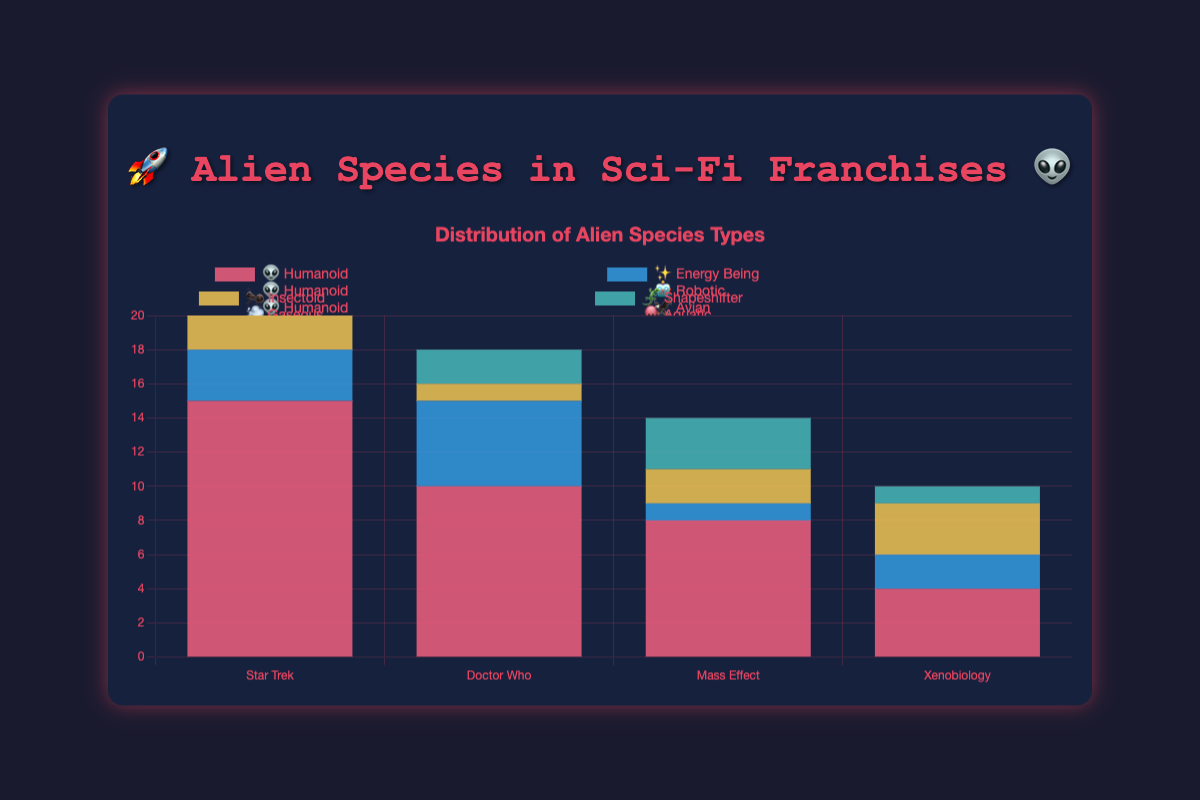What is the title of the chart? The title is displayed above the chart and should briefly describe the content. In this case, it is clearly stated at the top.
Answer: 🚀 Alien Species in Sci-Fi Franchises 👽 Which alien type has the highest count in the "Star Trek" franchise? By observing the bars corresponding to the "Star Trek" franchise, the tallest bar indicates the alien type with the highest count. The "Humanoid" type (👽) has the highest count.
Answer: Humanoid 👽 How many "Energy Being" (✨) aliens are there in "Star Trek"? Look at the specific bar for "Energy Being" (✨) in the "Star Trek" section of the chart. It shows a count of 3.
Answer: 3 Which franchise has the most "Robotic" (🤖) aliens? Compare the "Robotic" (🤖) bars across all franchises. "Doctor Who" has the highest bar for "Robotic" type with a count of 5.
Answer: Doctor Who What is the total number of "Humanoid" (👽) aliens across all franchises? Sum the counts of "Humanoid" aliens for each franchise: 15 (Star Trek) + 10 (Doctor Who) + 8 (Mass Effect) = 33.
Answer: 33 Are there any franchises with "Aquatic" (🐙) aliens? If so, which ones? Inspect the chart for any bars labeled "Aquatic" (🐙). The "Doctor Who" franchise has a bar for "Aquatic" aliens.
Answer: Doctor Who Which franchise has the least variety of alien types? Look at the number of different alien type bars for each franchise. "Mass Effect" has 4 types, while "Xenobiology" has more varied types but groups similar ones together.
Answer: Star Trek How does the count of "Synthetic" (🤖) aliens in "Mass Effect" compare to "Robotic" (🤖) aliens in "Doctor Who"? Compare the respective bars. "Mass Effect" has 3 "Synthetic" (🤖) aliens, and "Doctor Who" has 5 "Robotic" (🤖) aliens.
Answer: Doctor Who has more Which franchise features unique alien types not found in others? Identify alien types in each franchise that are not repeated in others. "Xenobiology" features unique types like "Fungal" (🍄) and "Crystalline" (💎).
Answer: Xenobiology What is the average count of alien species per type in the "Xenobiology" franchise? Add the counts for all alien types in "Xenobiology" and divide by the number of types: (4 + 2 + 3 + 1) / 4 = 2.5.
Answer: 2.5 